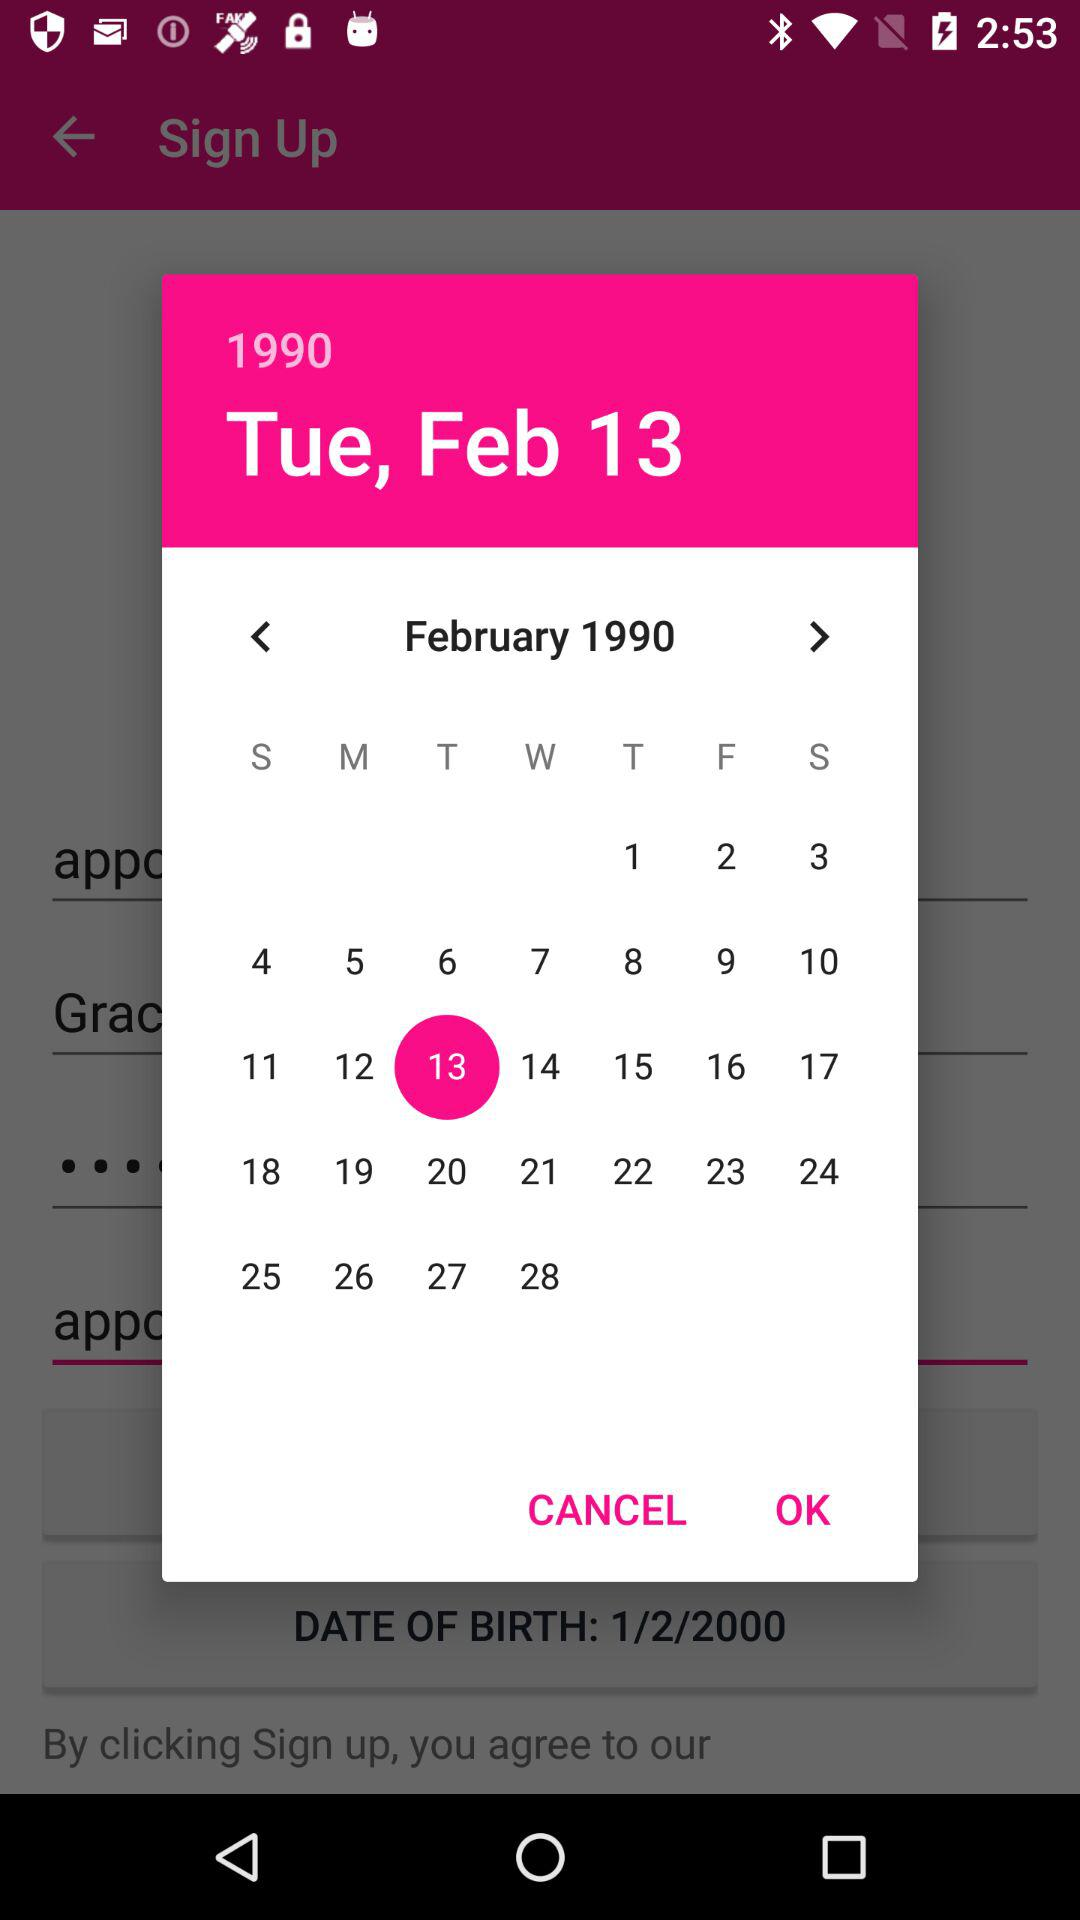What is the selected date? The selected date is Tuesday, February 13, 1990. 